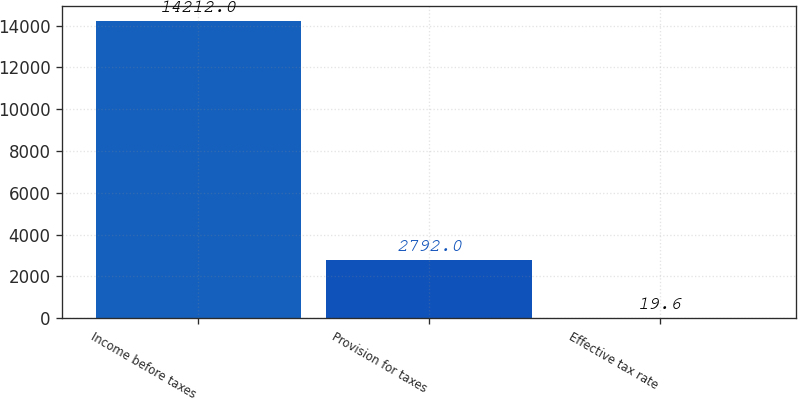Convert chart. <chart><loc_0><loc_0><loc_500><loc_500><bar_chart><fcel>Income before taxes<fcel>Provision for taxes<fcel>Effective tax rate<nl><fcel>14212<fcel>2792<fcel>19.6<nl></chart> 